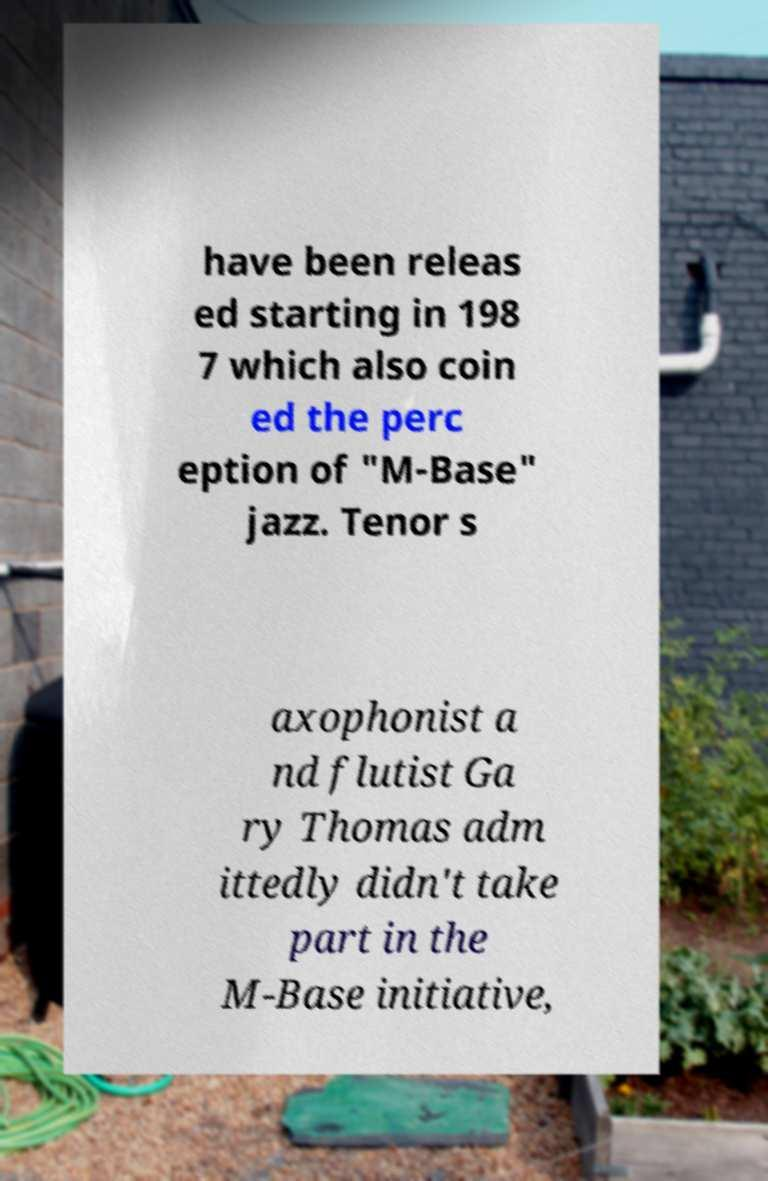For documentation purposes, I need the text within this image transcribed. Could you provide that? have been releas ed starting in 198 7 which also coin ed the perc eption of "M-Base" jazz. Tenor s axophonist a nd flutist Ga ry Thomas adm ittedly didn't take part in the M-Base initiative, 